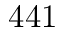Convert formula to latex. <formula><loc_0><loc_0><loc_500><loc_500>4 4 1</formula> 